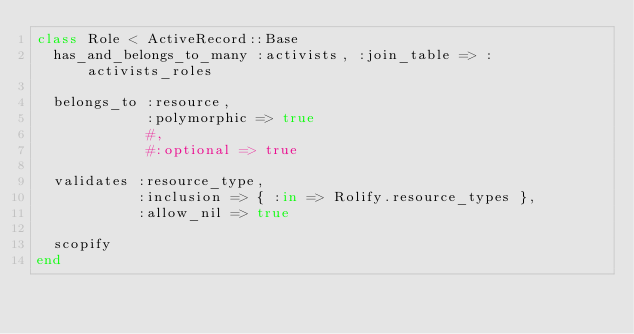Convert code to text. <code><loc_0><loc_0><loc_500><loc_500><_Ruby_>class Role < ActiveRecord::Base
  has_and_belongs_to_many :activists, :join_table => :activists_roles

  belongs_to :resource,
             :polymorphic => true
             #,
             #:optional => true

  validates :resource_type,
            :inclusion => { :in => Rolify.resource_types },
            :allow_nil => true

  scopify
end
</code> 